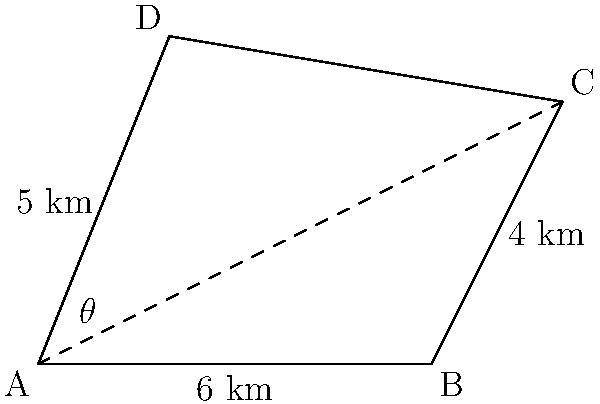A biologist has identified an irregularly shaped habitat zone for a rare species. Using satellite imagery and trigonometric formulas, calculate the area of this habitat zone. The zone is represented by the quadrilateral ABCD in the image, where AB = 6 km, AD = 5 km, BC = 4 km, and the angle at A (θ) is 53°. How can you determine the area of this habitat zone to help integrate this information into the school's science curriculum? To find the area of the irregularly shaped habitat zone, we can divide the quadrilateral into two triangles and calculate their areas separately. Here's a step-by-step approach:

1) Divide the quadrilateral ABCD into triangles ABC and ACD by drawing the diagonal AC.

2) For triangle ABC:
   - We know the base AB = 6 km and the height BC = 4 km
   - Area of ABC = $\frac{1}{2} \times base \times height = \frac{1}{2} \times 6 \times 4 = 12$ sq km

3) For triangle ACD:
   - We know the side AD = 5 km and the angle at A (θ) = 53°
   - We need to find the height of this triangle perpendicular to AC
   - Height = $5 \times \sin(53°) = 3.98$ km (rounded to 2 decimal places)
   
4) To find the base of triangle ACD (which is AC), we can use the Pythagorean theorem in triangle ABC:
   $AC^2 = AB^2 + BC^2 = 6^2 + 4^2 = 52$
   $AC = \sqrt{52} = 7.21$ km (rounded to 2 decimal places)

5) Now we can calculate the area of triangle ACD:
   Area of ACD = $\frac{1}{2} \times base \times height = \frac{1}{2} \times 7.21 \times 3.98 = 14.35$ sq km

6) The total area of the habitat zone is the sum of the areas of both triangles:
   Total Area = Area of ABC + Area of ACD = $12 + 14.35 = 26.35$ sq km

Therefore, the area of the irregularly shaped habitat zone is approximately 26.35 square kilometers.
Answer: 26.35 sq km 